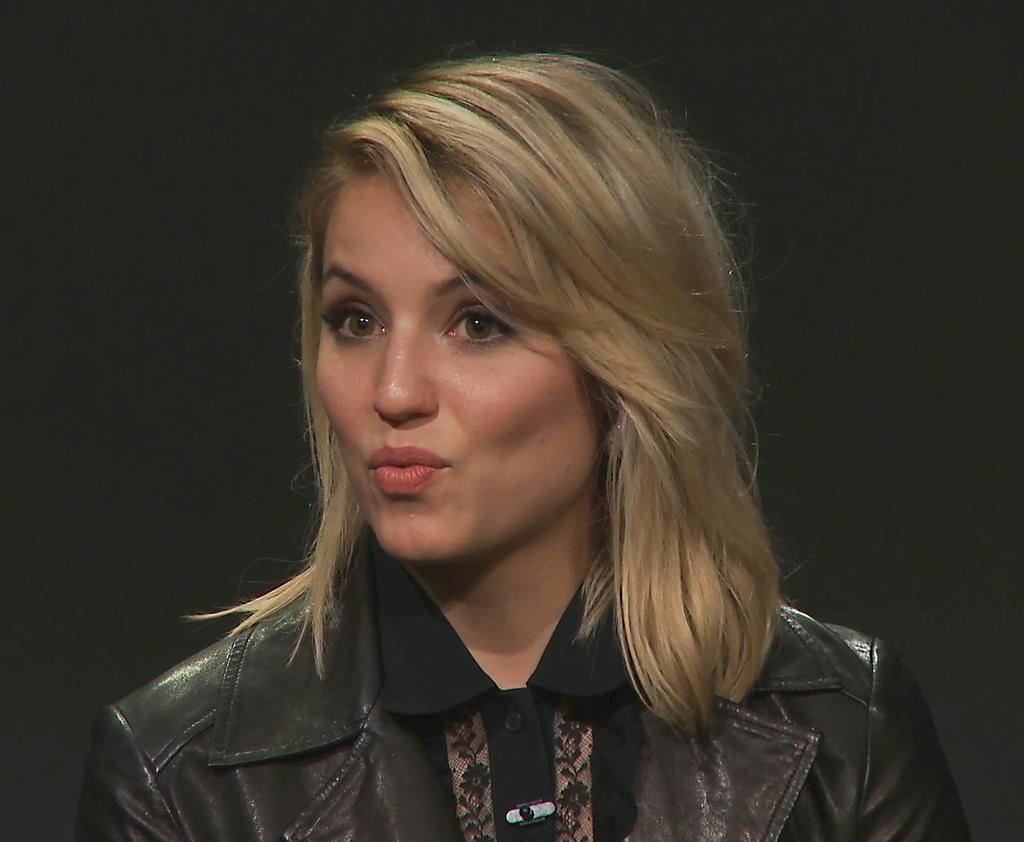Who is the main subject in the image? There is a woman in the image. What can be observed about the background of the image? The background of the image is dark. What type of plough is the woman using in the image? There is no plough present in the image; it features a woman in a dark background. Can you tell me about the government's involvement in the image? There is no reference to the government or its involvement in the image. 